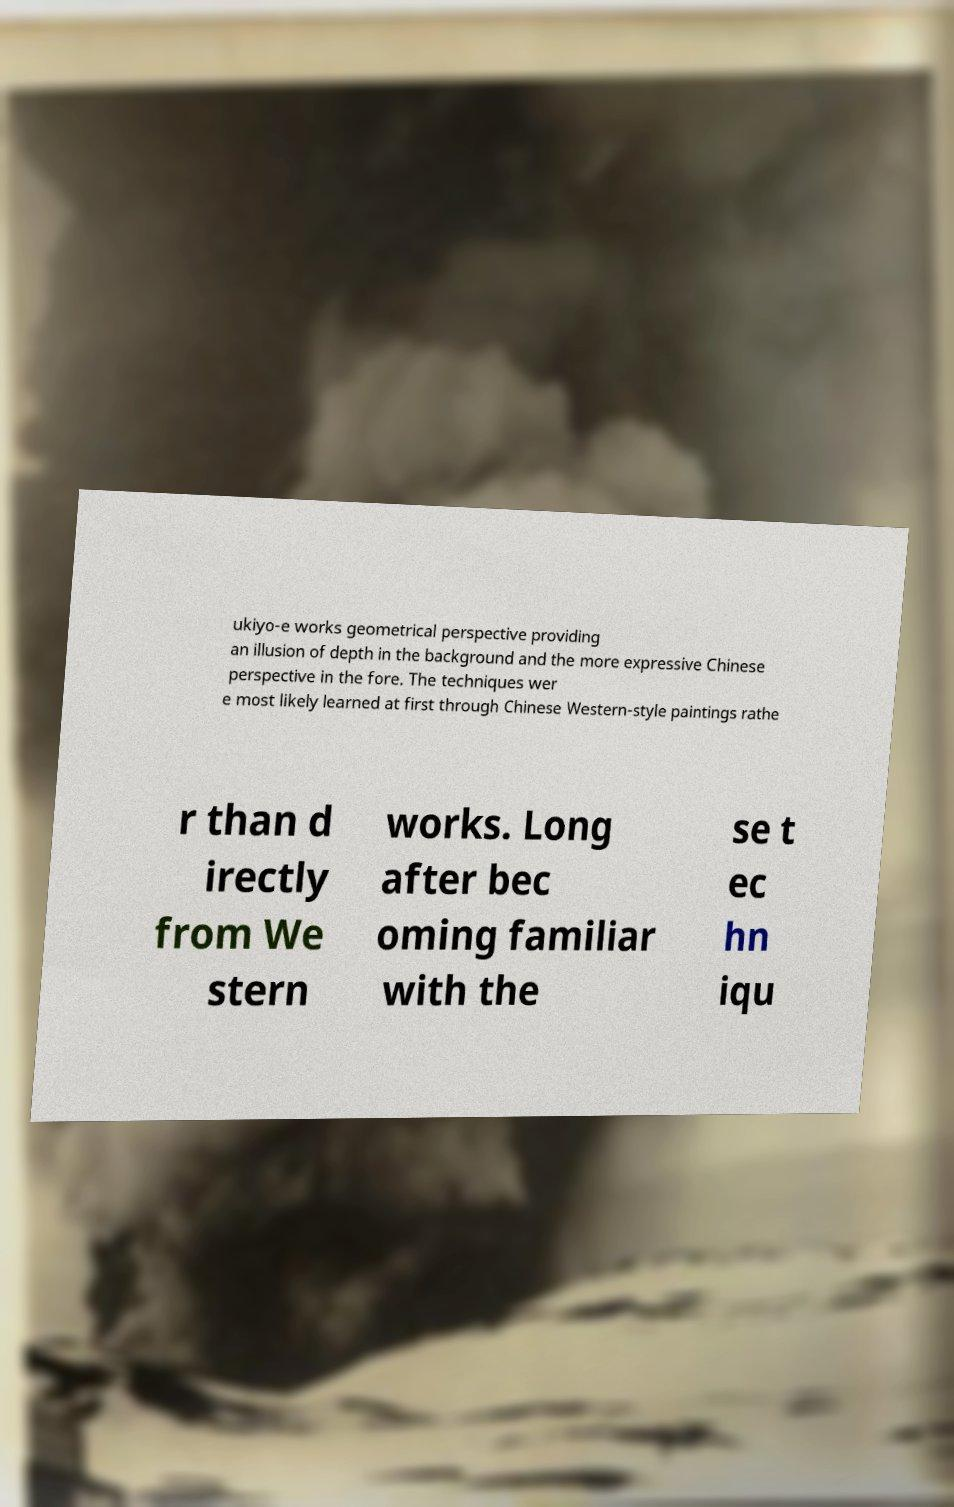Can you accurately transcribe the text from the provided image for me? ukiyo-e works geometrical perspective providing an illusion of depth in the background and the more expressive Chinese perspective in the fore. The techniques wer e most likely learned at first through Chinese Western-style paintings rathe r than d irectly from We stern works. Long after bec oming familiar with the se t ec hn iqu 